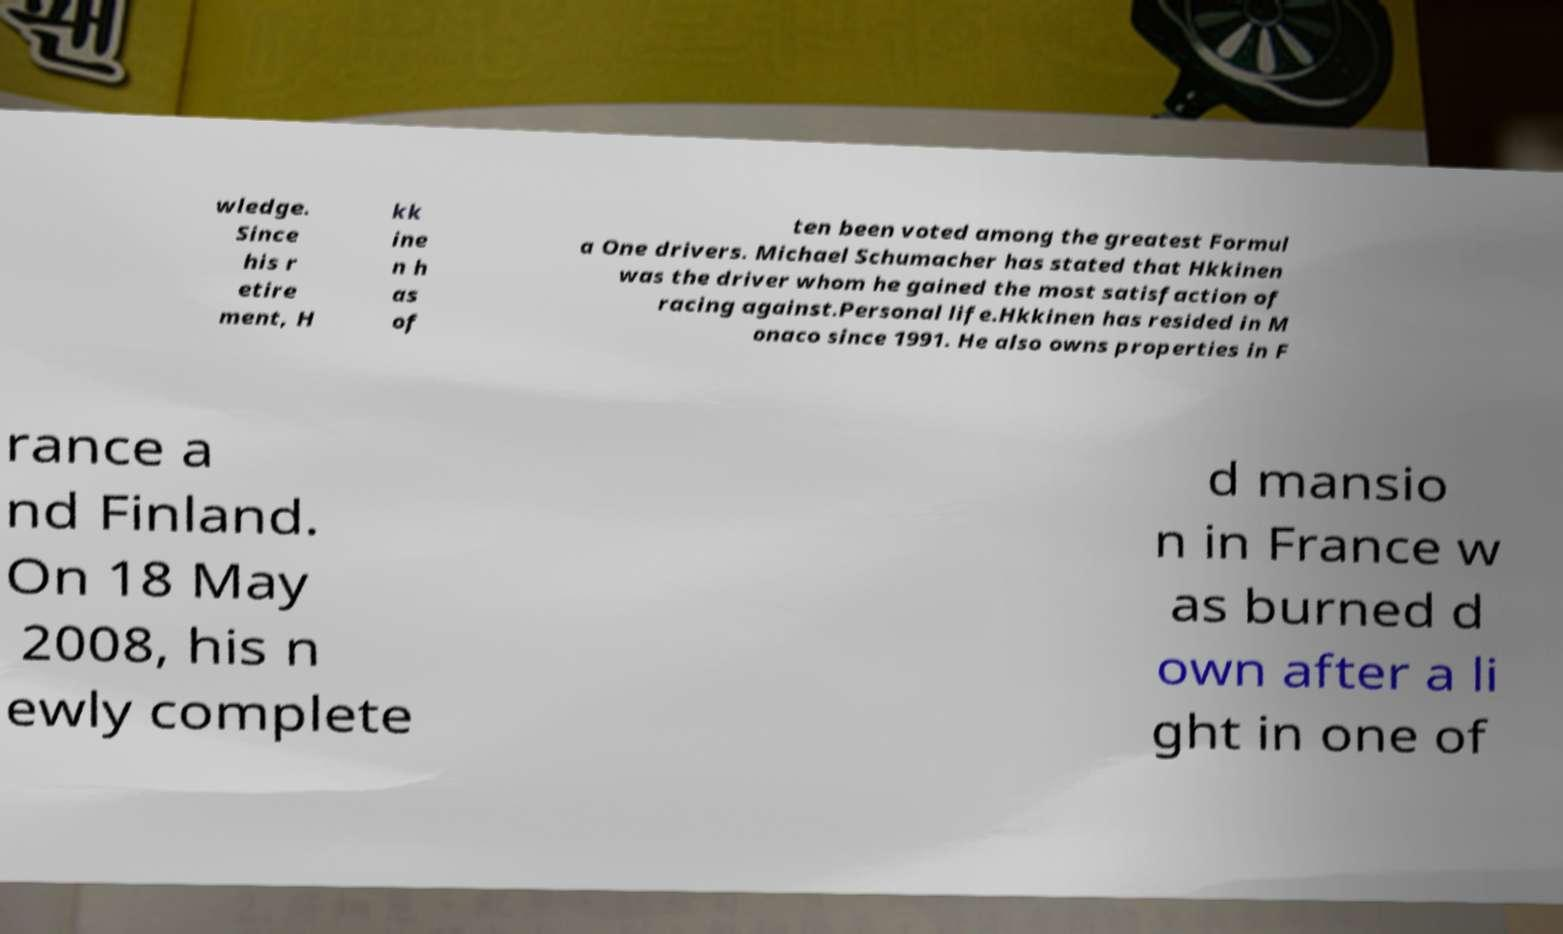Please identify and transcribe the text found in this image. wledge. Since his r etire ment, H kk ine n h as of ten been voted among the greatest Formul a One drivers. Michael Schumacher has stated that Hkkinen was the driver whom he gained the most satisfaction of racing against.Personal life.Hkkinen has resided in M onaco since 1991. He also owns properties in F rance a nd Finland. On 18 May 2008, his n ewly complete d mansio n in France w as burned d own after a li ght in one of 